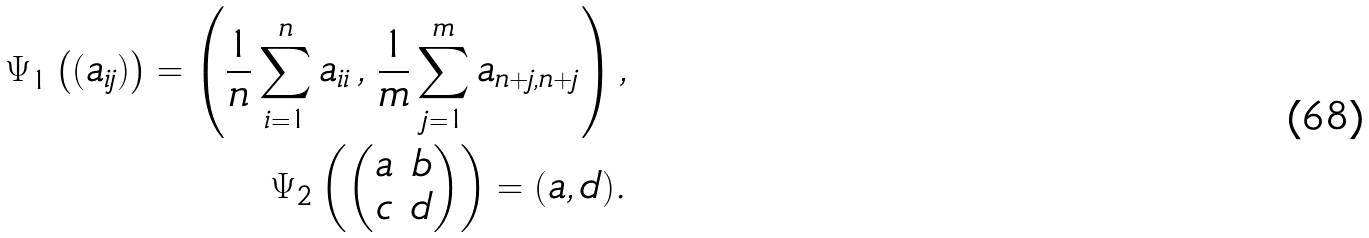Convert formula to latex. <formula><loc_0><loc_0><loc_500><loc_500>\Psi _ { 1 } \left ( ( a _ { i j } ) \right ) = \left ( \frac { 1 } { n } \sum _ { i = 1 } ^ { n } a _ { i i } \, , \, \frac { 1 } { m } \sum _ { j = 1 } ^ { m } a _ { n + j , n + j } \right ) , \\ \Psi _ { 2 } \left ( \begin{pmatrix} a & b \\ c & d \end{pmatrix} \right ) = ( a , d ) .</formula> 